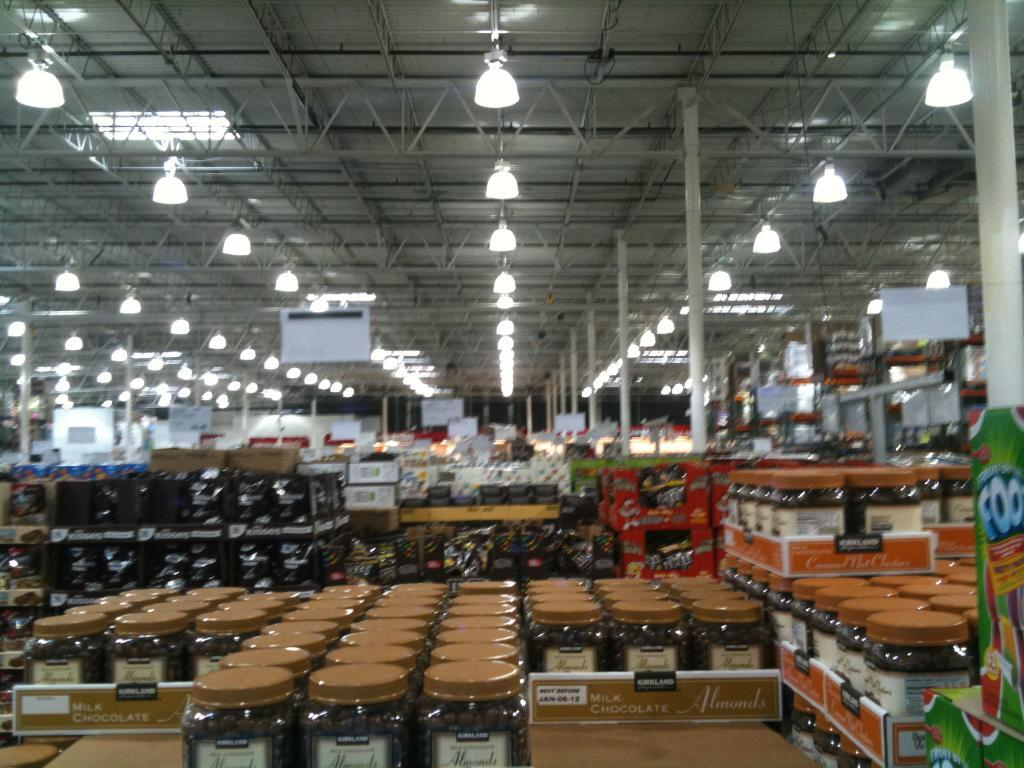What type of structure can be seen in the image? There are racks in the image. What objects are stored on the racks? Jars are visible in the image. What can be seen in the background of the image? There are poles in the background of the image. What is located at the top of the image? There are lights at the top of the image. What type of surface is visible in the image? There are boards visible in the image. What type of flooring can be seen in the image? There is no flooring visible in the image; the focus is on the racks, jars, poles, lights, and boards. 